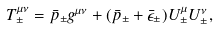Convert formula to latex. <formula><loc_0><loc_0><loc_500><loc_500>T ^ { \mu \nu } _ { \pm } & = \bar { p } _ { \pm } g ^ { \mu \nu } + ( \bar { p } _ { \pm } + \bar { \epsilon } _ { \pm } ) U ^ { \mu } _ { \pm } U ^ { \nu } _ { \pm } ,</formula> 